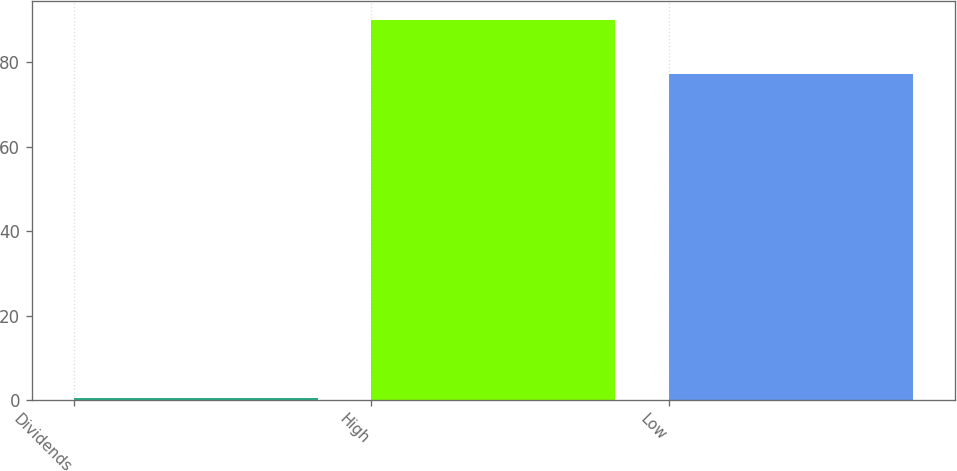<chart> <loc_0><loc_0><loc_500><loc_500><bar_chart><fcel>Dividends<fcel>High<fcel>Low<nl><fcel>0.55<fcel>90.14<fcel>77.29<nl></chart> 